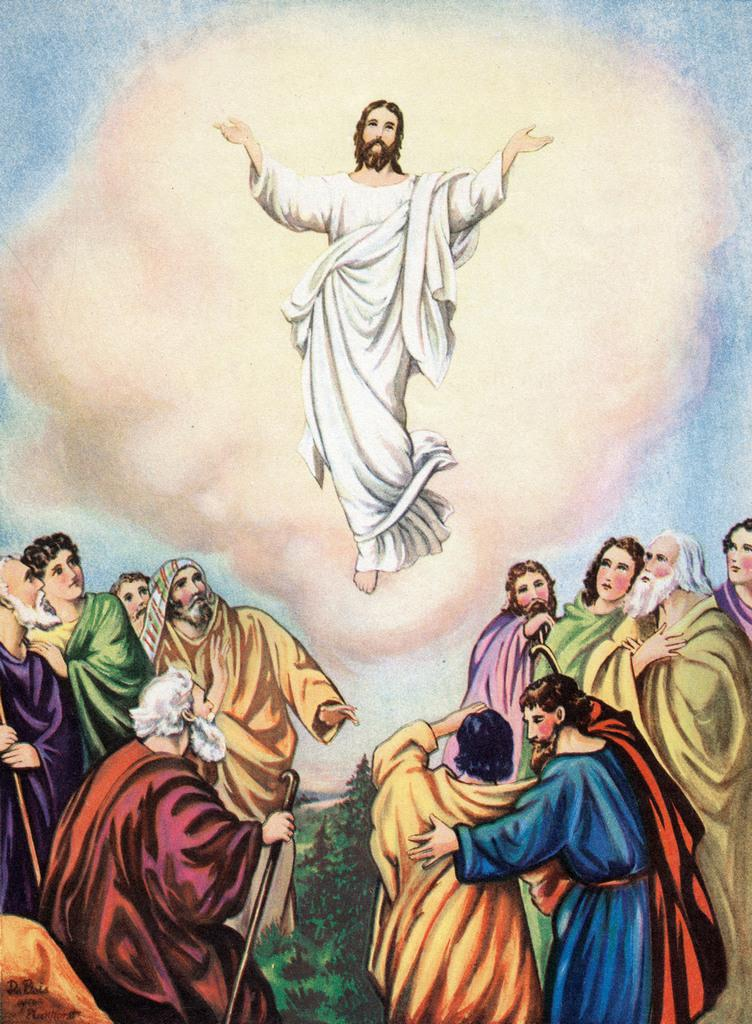What is the main subject of the image? The main subject of the image is a painting. What is happening in the painting? The painting depicts persons standing on the ground and includes trees. Is there anything unusual happening in the painting? Yes, there is a person flying in the air in the painting. What route does the sponge take to reach the letter in the image? There is no sponge or letter present in the image, so this question cannot be answered. 